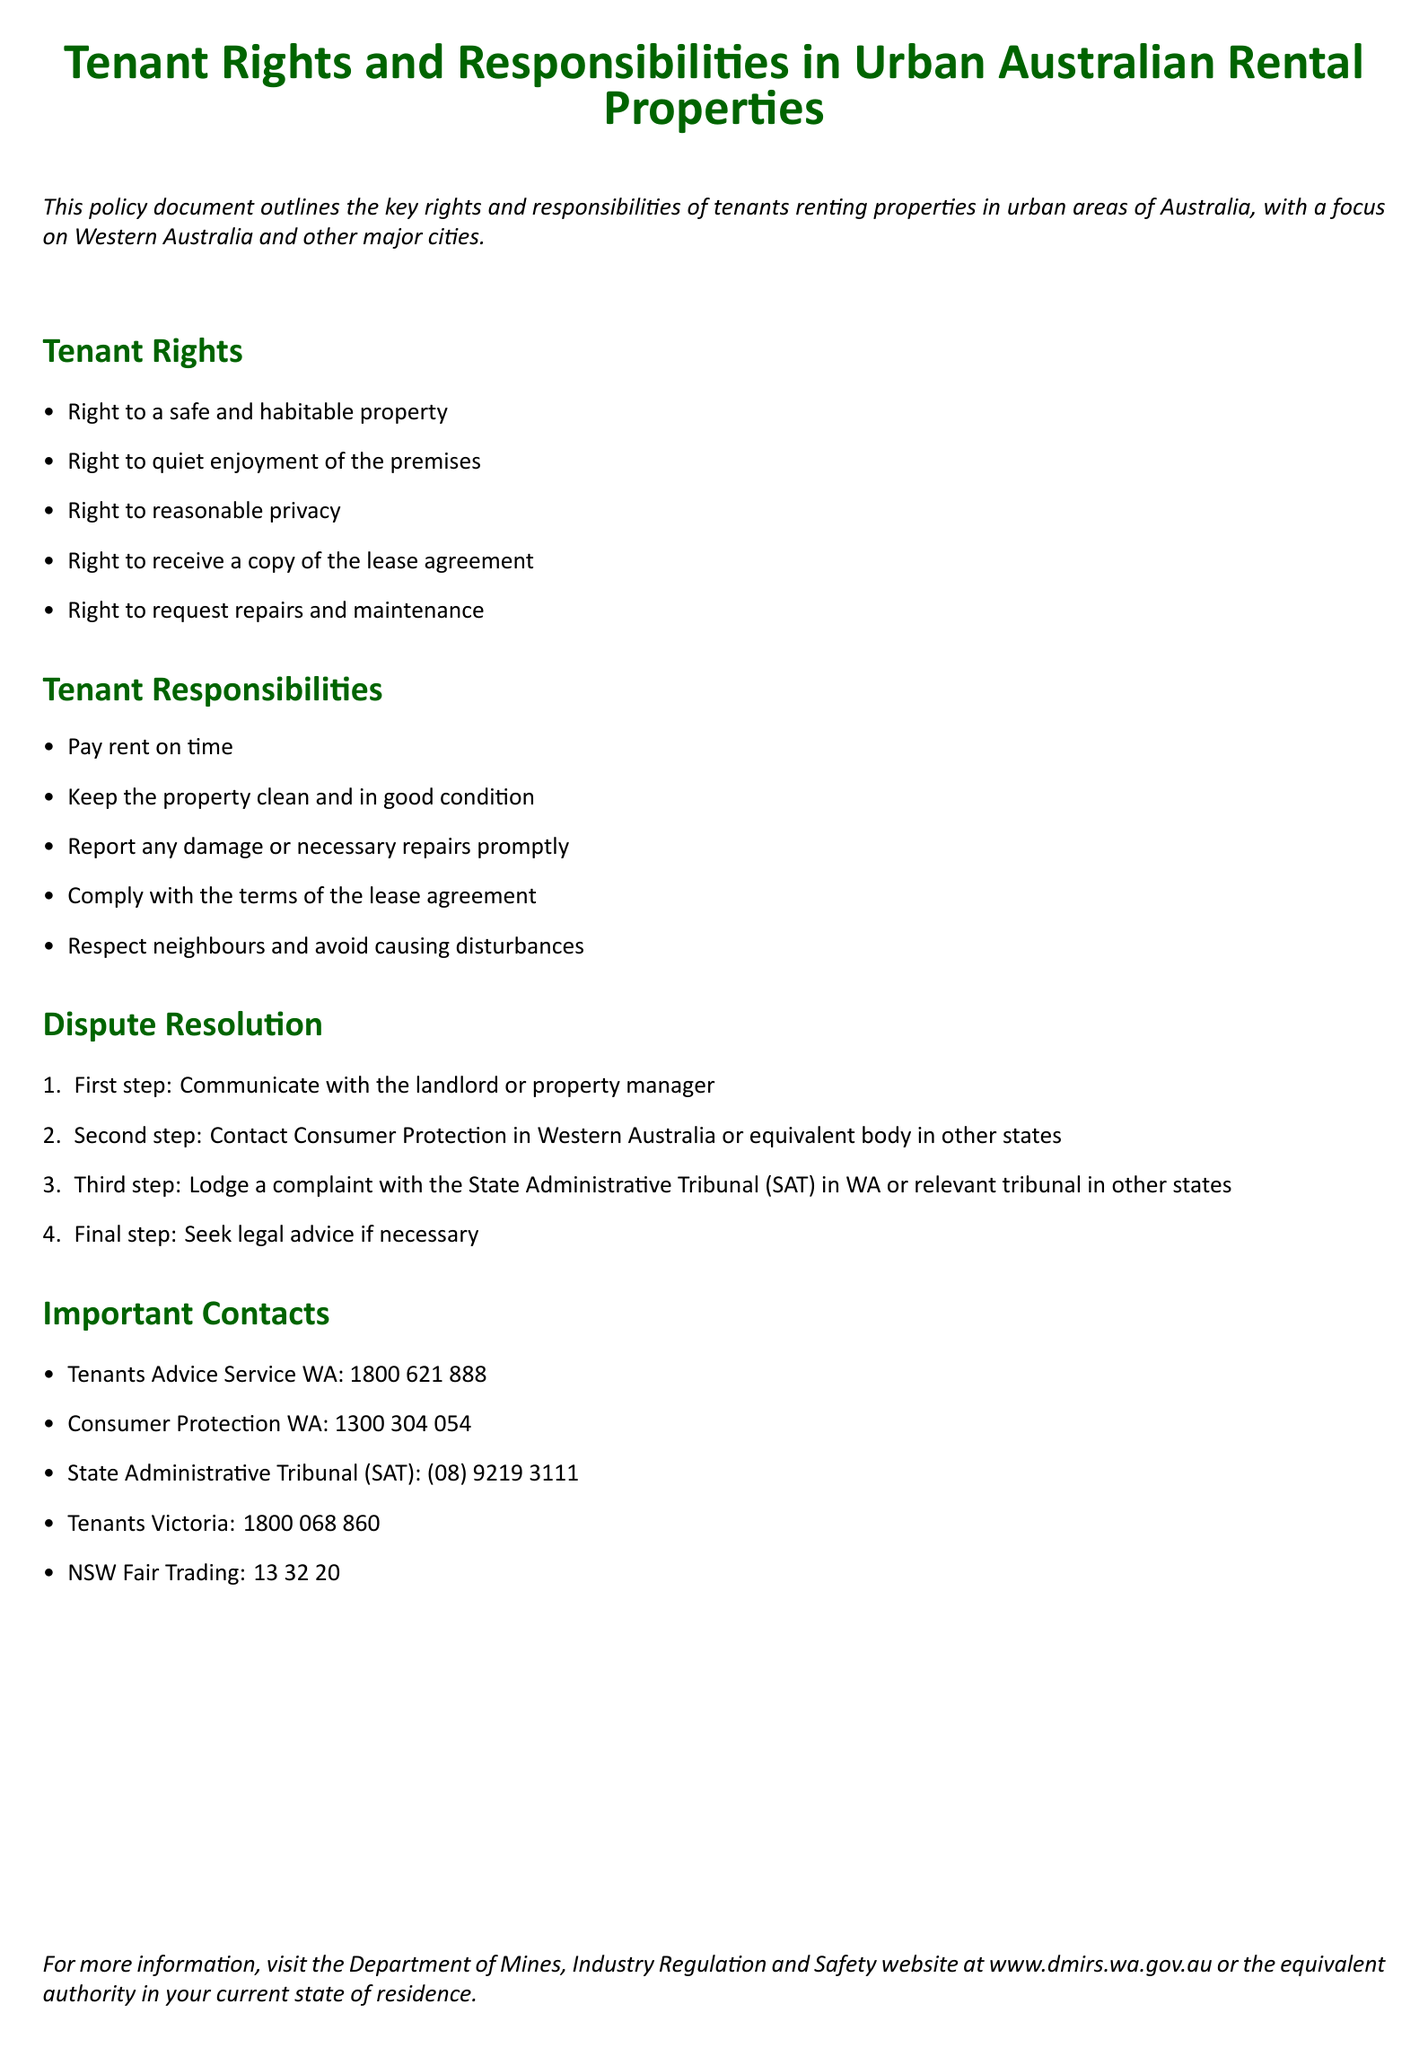What are the tenant's rights? The rights listed in the document include a safe property, quiet enjoyment, reasonable privacy, a copy of the lease, and maintenance requests.
Answer: Safe and habitable property, quiet enjoyment, reasonable privacy, copy of the lease agreement, request repairs and maintenance What is the first step in the dispute resolution process? The first step in resolving disputes is to communicate with the landlord or property manager, as stated in the document.
Answer: Communicate with the landlord or property manager What organization provides tenant advice in Western Australia? The document mentions Tenants Advice Service WA as a contact for tenant advice.
Answer: Tenants Advice Service WA What is one of the tenant responsibilities? One of the responsibilities is to keep the property clean and in good condition, as outlined in the document.
Answer: Keep the property clean and in good condition What is the phone number for Consumer Protection WA? The document specifies the contact number for Consumer Protection WA for tenant-related issues.
Answer: 1300 304 054 How many steps are there in the dispute resolution process? The document lists four steps involved in the dispute resolution process.
Answer: Four steps 